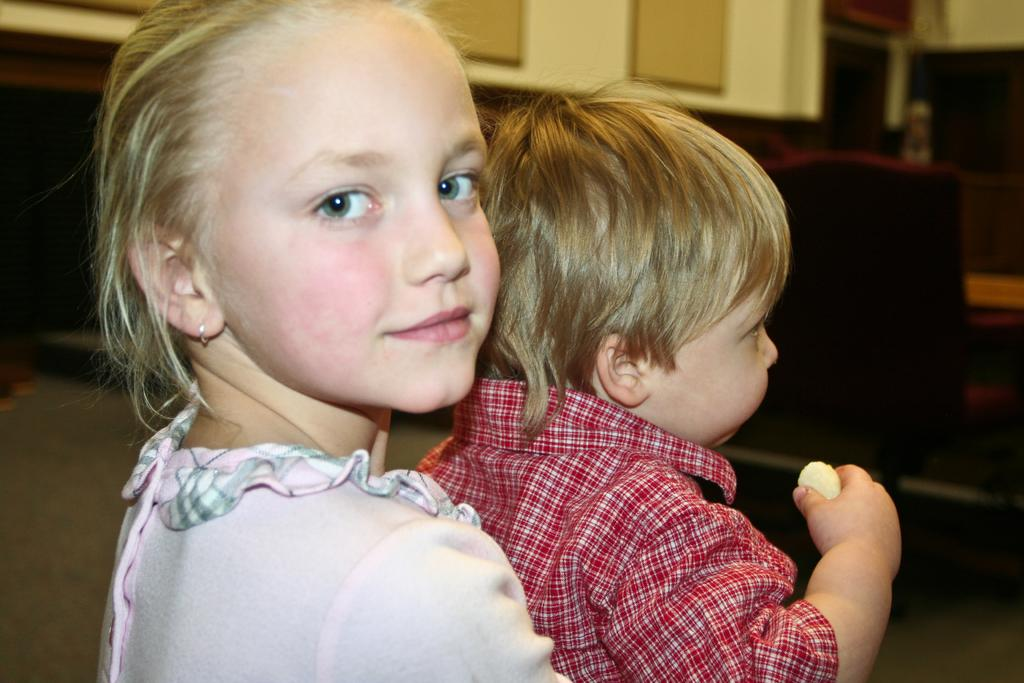Who is present in the image? There is a little girl and a little boy in the image. What is the girl wearing? The girl is wearing a pink dress. What is the boy wearing? The boy is wearing a red shirt. What direction is the girl looking in? The girl is looking at one side. What type of alarm is the little girl holding in the image? There is no alarm present in the image; the girl is not holding anything. 